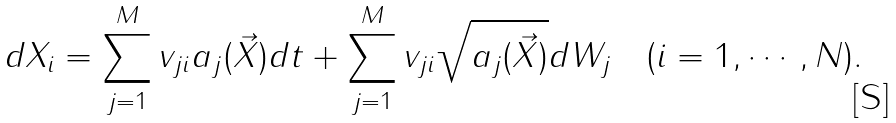<formula> <loc_0><loc_0><loc_500><loc_500>d X _ { i } = \sum _ { j = 1 } ^ { M } v _ { j i } a _ { j } ( \vec { X } ) d t + \sum _ { j = 1 } ^ { M } v _ { j i } \sqrt { a _ { j } ( \vec { X } ) } d W _ { j } \quad ( i = 1 , \cdots , N ) .</formula> 